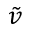Convert formula to latex. <formula><loc_0><loc_0><loc_500><loc_500>\tilde { v }</formula> 